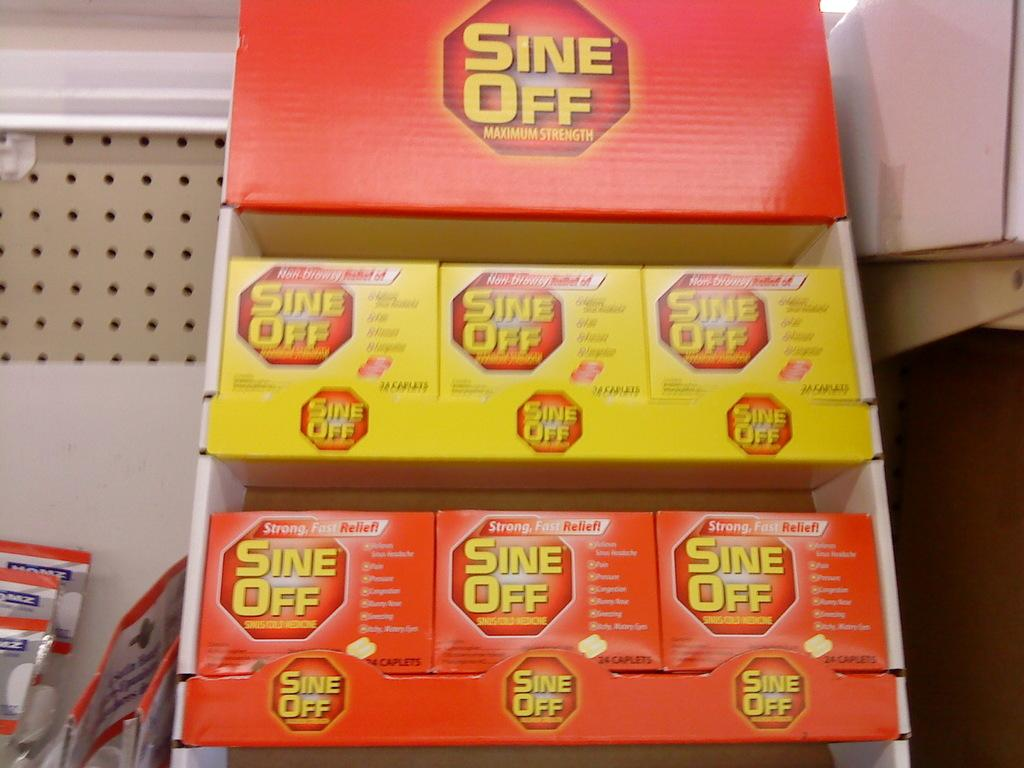What is arranged on the shelves in the image? There are boxes arranged on the shelves. What can be seen on the white wall in the background? In the background, there are packets on a white wall. What type of furniture is visible in the image? There is no furniture visible in the image; it only shows boxes on shelves and packets on a white wall. Is there a note attached to any of the boxes in the image? There is no mention of a note in the provided facts, so it cannot be determined if there is a note attached to any of the boxes. 